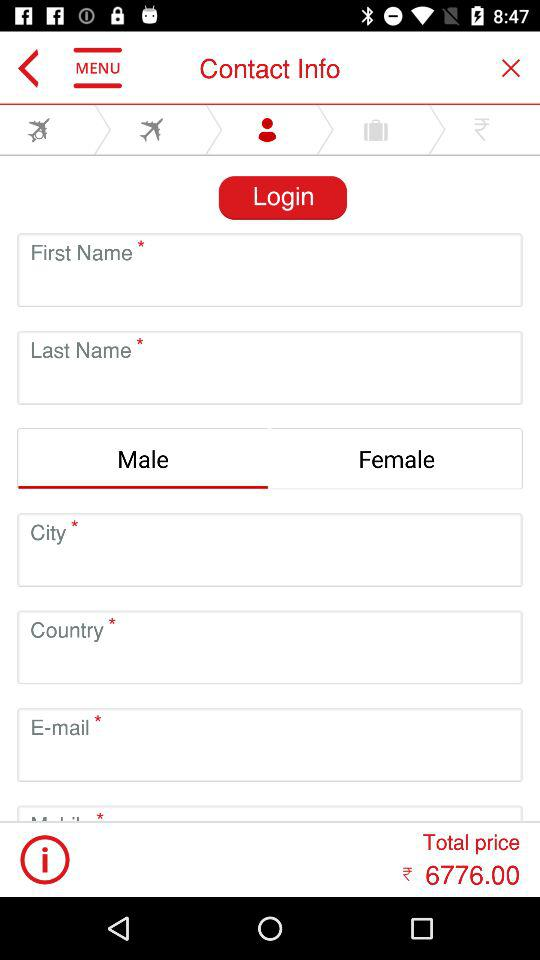Which tab is selected? The selected tab is "Contact Info". 